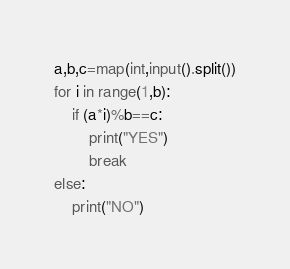Convert code to text. <code><loc_0><loc_0><loc_500><loc_500><_Python_>a,b,c=map(int,input().split())
for i in range(1,b):
    if (a*i)%b==c:
        print("YES")
        break
else:
    print("NO")</code> 